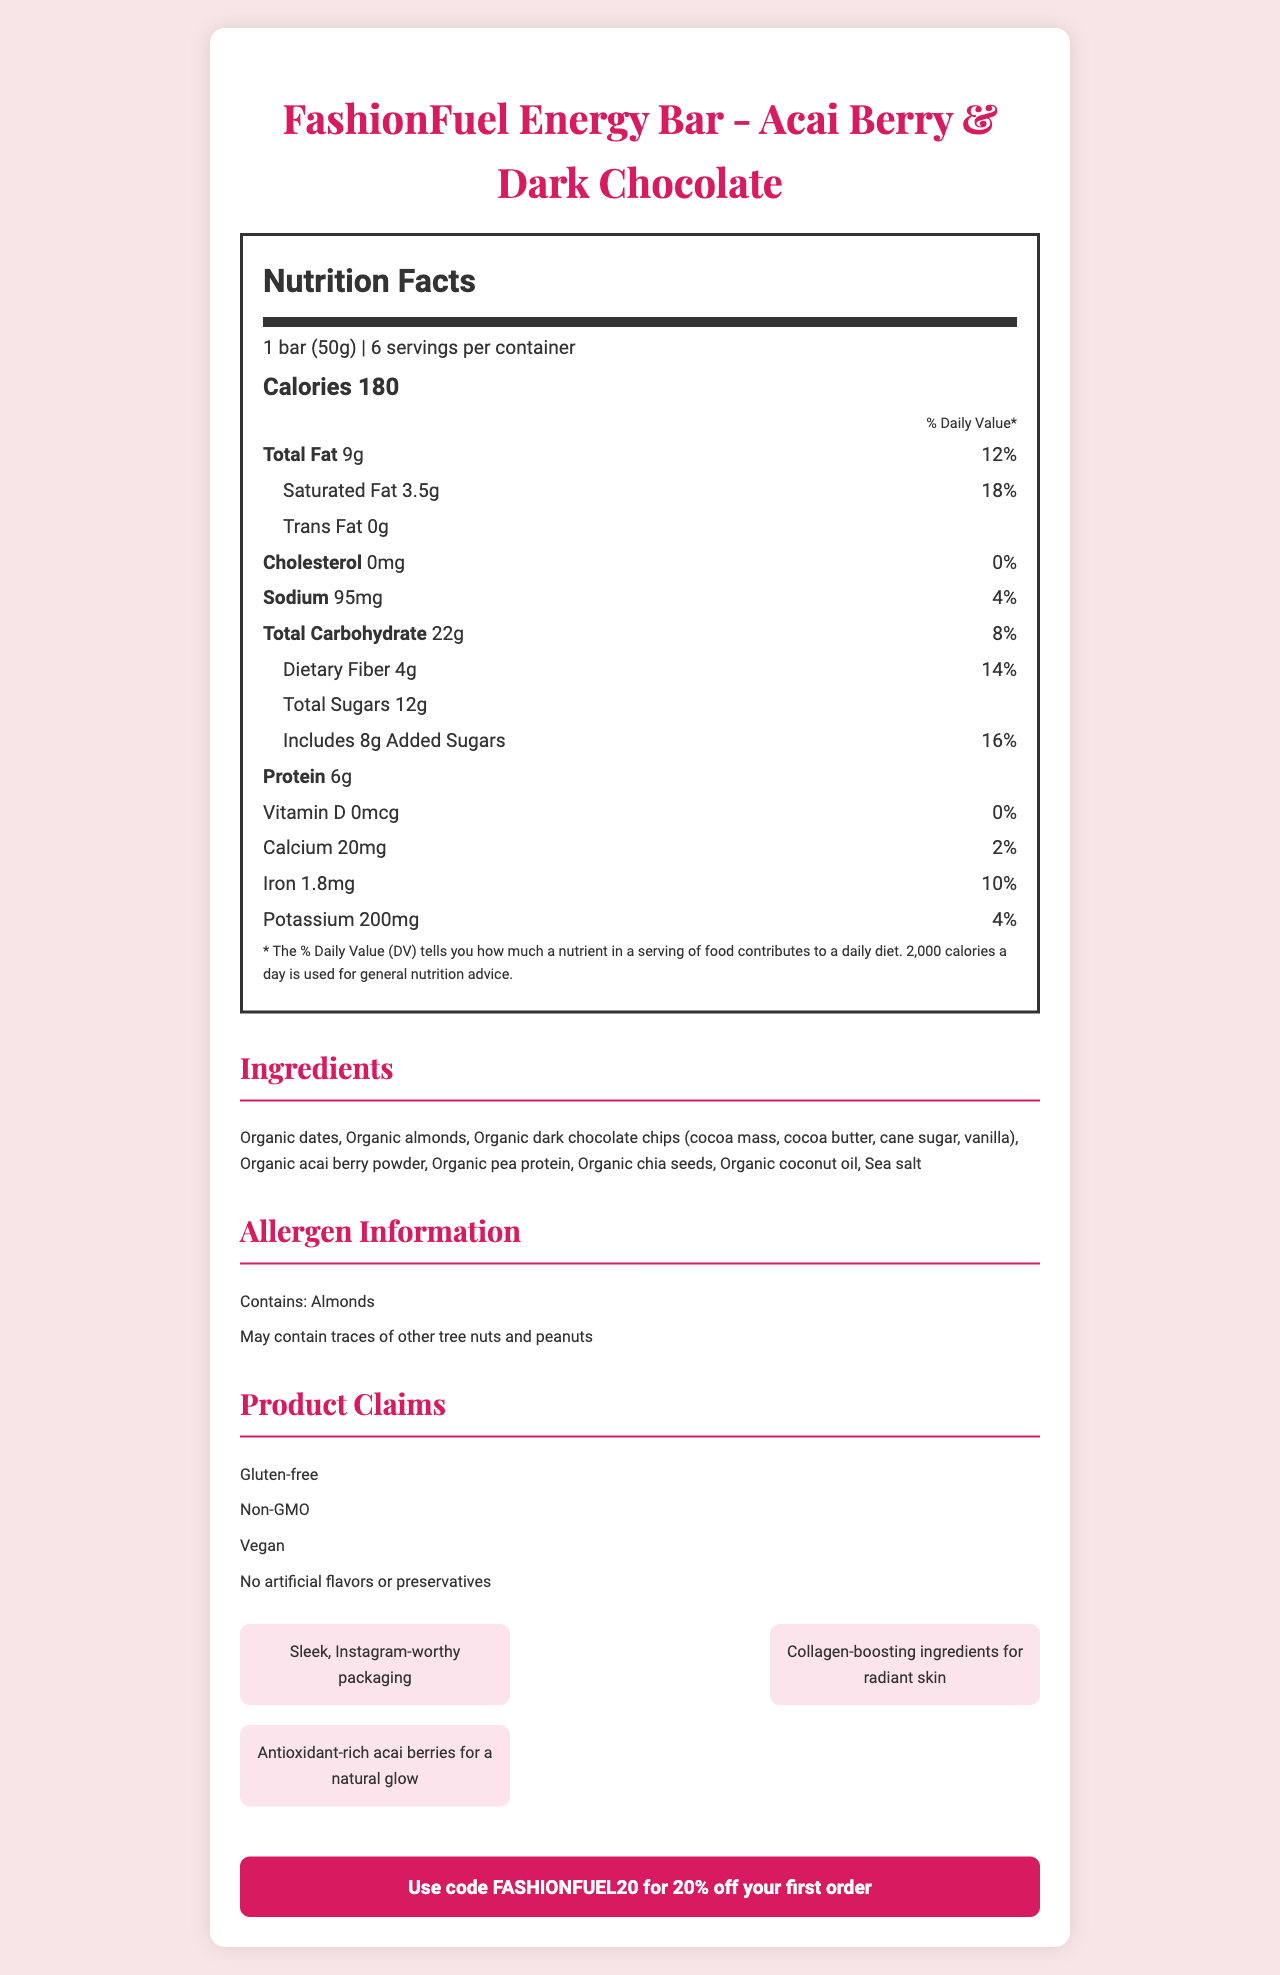what is the serving size for the FashionFuel Energy Bar? The serving size is explicitly mentioned in the document as "1 bar (50g)".
Answer: 1 bar (50g) how many calories are there per serving? The document states that each serving contains 180 calories.
Answer: 180 what is the percentage daily value of saturated fat? The percentage daily value of saturated fat is displayed as 18%.
Answer: 18% how much dietary fiber does one serving contain? The document indicates that one serving contains 4 grams of dietary fiber.
Answer: 4g which vitamin is not present in the FashionFuel Energy Bar? The document shows that vitamin D has a value of 0mcg, indicating its absence.
Answer: Vitamin D how many servings are there per container? The document states that there are 6 servings per container.
Answer: 6 servings what are some of the main ingredients in the FashionFuel Energy Bar? The main ingredients listed include organic dates, organic almonds, organic dark chocolate chips, and organic acai berry powder.
Answer: Organic dates, Organic almonds, Organic dark chocolate chips, Organic acai berry powder what allergens are present in the FashionFuel Energy Bar? A. Milk B. Wheat C. Almonds D. Soy The document mentions that the product contains almonds and may contain traces of other tree nuts and peanuts.
Answer: C. Almonds what is the main source of protein in the FashionFuel Energy Bar? A. Whey Protein B. Pea Protein C. Soy Protein D. Rice Protein The ingredients list includes organic pea protein as the main source of protein.
Answer: B. Pea Protein are there any artificial flavors or preservatives in the FashionFuel Energy Bar? The document claims "No artificial flavors or preservatives," indicating that there are none present.
Answer: No is the FashionFuel Energy Bar gluten-free? The marketing claims section lists "Gluten-free," confirming that the product is gluten-free.
Answer: Yes describe the main marketing focus of the FashionFuel Energy Bar. The document highlights the fashion-forward features, health benefits, and appeal to fashion-conscious consumers, along with essential nutritional facts and a discount offer.
Answer: The FashionFuel Energy Bar, flavored with Acai Berry & Dark Chocolate, targets fashionistas with a focus on being a nutritious, stylish, and functional snack. It features sleek packaging, claims to boost collagen for radiant skin, includes antioxidant-rich ingredients, and is gluten-free, non-GMO, and vegan. Additionally, it provides an exclusive discount. what is the amount of calcium per serving? The document states that there are 20mg of calcium per serving.
Answer: 20mg what percentage daily value of added sugars is in one serving? The percentage daily value for added sugars is given as 16%.
Answer: 16% how much sodium is in a serving of the FashionFuel Energy Bar? The document lists the sodium content as 95mg per serving.
Answer: 95mg are there any peanuts in the FashionFuel Energy Bar? According to the allergen information, the product may contain traces of peanuts.
Answer: May contain traces how many grams of total fat does one serving of the FashionFuel Energy Bar contain? The document lists the total fat content as 9g per serving.
Answer: 9g what are the fashion-forward features of the FashionFuel Energy Bar? The document details the fashion-forward features as including sleek packaging, collagen-boosting ingredients, and antioxidant-rich acai berries.
Answer: Sleek, Instagram-worthy packaging, Collagen-boosting ingredients, Antioxidant-rich acai berries do all the ingredients in the FashionFuel Energy Bar appear to be organic? The document lists all ingredients with the prefix "organic," indicating that they are all organic.
Answer: Yes what is the exclusive discount code mentioned for the FashionFuel Energy Bar? The document provides the exclusive discount code "FASHIONFUEL20" for 20% off the first order.
Answer: FASHIONFUEL20 why are collagen-boosting ingredients included in the FashionFuel Energy Bar? The document states that collagen-boosting ingredients are included for radiant skin.
Answer: For radiant skin what is the daily value percentage of potassium in the FashionFuel Energy Bar? The document lists the daily value percentage of potassium as 4%.
Answer: 4% what is the most notable design feature of the FashionFuel Energy Bar's packaging? The document specifically mentions "sleek, Instagram-worthy packaging" as a notable design feature.
Answer: Sleek, Instagram-worthy packaging does the FashionFuel Energy Bar contain any iron? The document states that there is 1.8mg of iron, equaling 10% of the daily value.
Answer: Yes 